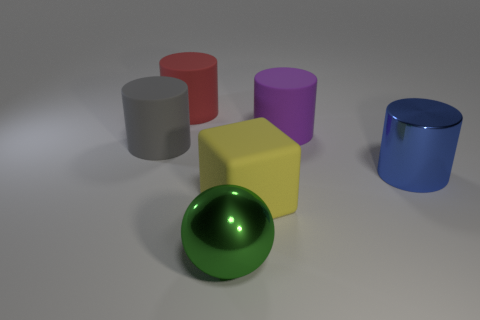Are there more matte things than tiny gray shiny objects?
Provide a short and direct response. Yes. There is a large shiny object behind the large green object; is it the same shape as the big purple rubber object?
Make the answer very short. Yes. Are there more red rubber things behind the metallic sphere than tiny purple shiny balls?
Your answer should be very brief. Yes. There is a big shiny thing that is on the left side of the cylinder in front of the large gray thing; what color is it?
Offer a terse response. Green. What number of matte things are there?
Offer a terse response. 4. How many things are both in front of the big purple cylinder and left of the large purple matte object?
Give a very brief answer. 3. Is there any other thing that is the same shape as the large green thing?
Offer a terse response. No. What shape is the large shiny object behind the big green metal object?
Offer a terse response. Cylinder. What number of other objects are the same material as the large gray thing?
Your answer should be compact. 3. What material is the big green sphere?
Offer a terse response. Metal. 